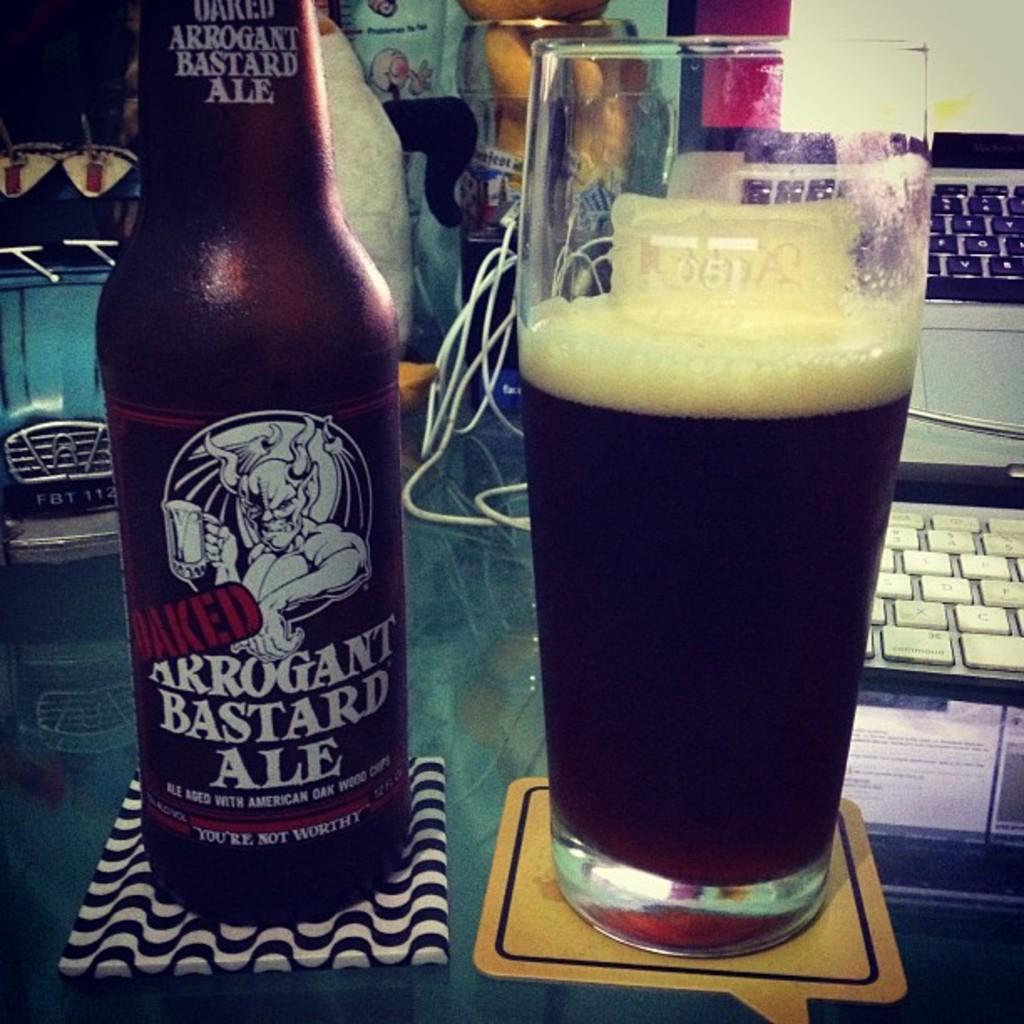What is the bottom line on the bottle?
Offer a very short reply. You're not worthy. What brand of ale is in the bottle?
Provide a succinct answer. Arrogant bastard. 